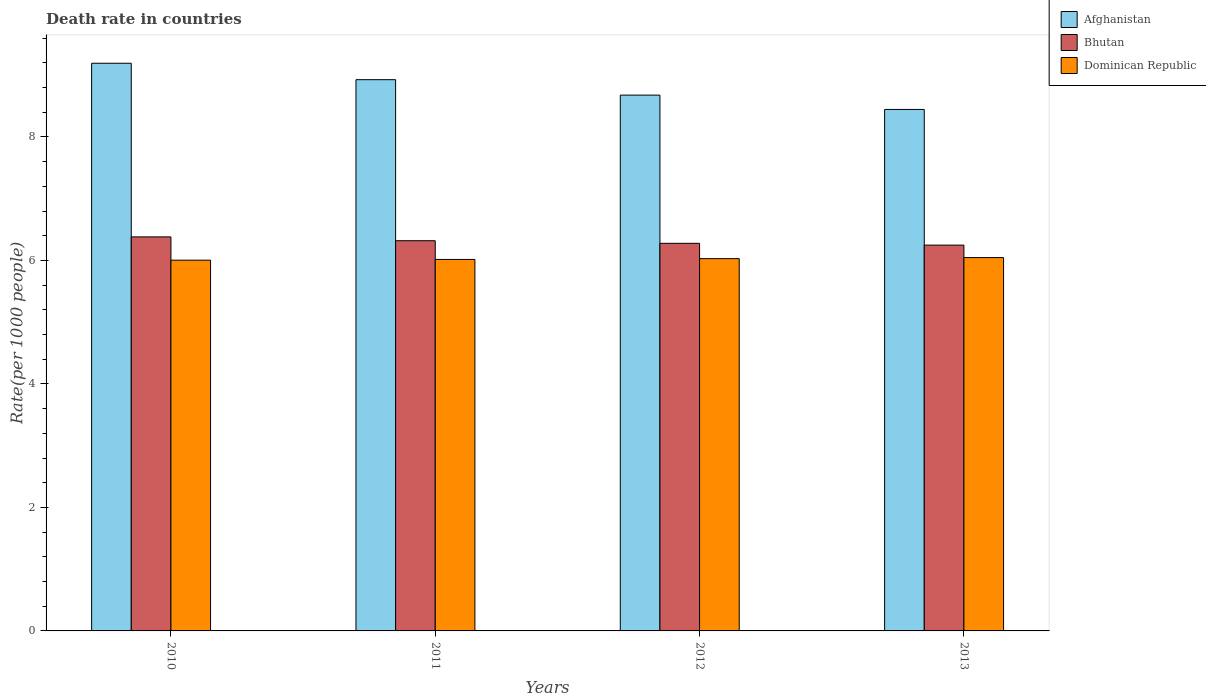What is the death rate in Dominican Republic in 2012?
Offer a very short reply. 6.03. Across all years, what is the maximum death rate in Afghanistan?
Keep it short and to the point. 9.19. Across all years, what is the minimum death rate in Afghanistan?
Ensure brevity in your answer.  8.45. In which year was the death rate in Bhutan maximum?
Your answer should be very brief. 2010. What is the total death rate in Afghanistan in the graph?
Offer a terse response. 35.24. What is the difference between the death rate in Afghanistan in 2011 and that in 2013?
Keep it short and to the point. 0.48. What is the difference between the death rate in Afghanistan in 2011 and the death rate in Dominican Republic in 2012?
Provide a short and direct response. 2.9. What is the average death rate in Dominican Republic per year?
Give a very brief answer. 6.02. In the year 2011, what is the difference between the death rate in Afghanistan and death rate in Dominican Republic?
Your answer should be very brief. 2.91. In how many years, is the death rate in Dominican Republic greater than 2.4?
Offer a terse response. 4. What is the ratio of the death rate in Afghanistan in 2012 to that in 2013?
Make the answer very short. 1.03. What is the difference between the highest and the second highest death rate in Dominican Republic?
Keep it short and to the point. 0.02. What is the difference between the highest and the lowest death rate in Afghanistan?
Make the answer very short. 0.75. In how many years, is the death rate in Afghanistan greater than the average death rate in Afghanistan taken over all years?
Give a very brief answer. 2. Is the sum of the death rate in Dominican Republic in 2012 and 2013 greater than the maximum death rate in Bhutan across all years?
Give a very brief answer. Yes. What does the 3rd bar from the left in 2012 represents?
Give a very brief answer. Dominican Republic. What does the 3rd bar from the right in 2010 represents?
Ensure brevity in your answer.  Afghanistan. Are all the bars in the graph horizontal?
Provide a short and direct response. No. How many years are there in the graph?
Provide a short and direct response. 4. What is the difference between two consecutive major ticks on the Y-axis?
Offer a very short reply. 2. Are the values on the major ticks of Y-axis written in scientific E-notation?
Offer a terse response. No. Does the graph contain grids?
Provide a succinct answer. No. Where does the legend appear in the graph?
Your answer should be very brief. Top right. How many legend labels are there?
Provide a short and direct response. 3. How are the legend labels stacked?
Offer a terse response. Vertical. What is the title of the graph?
Make the answer very short. Death rate in countries. What is the label or title of the Y-axis?
Provide a succinct answer. Rate(per 1000 people). What is the Rate(per 1000 people) of Afghanistan in 2010?
Your answer should be compact. 9.19. What is the Rate(per 1000 people) in Bhutan in 2010?
Offer a terse response. 6.38. What is the Rate(per 1000 people) of Dominican Republic in 2010?
Offer a terse response. 6. What is the Rate(per 1000 people) in Afghanistan in 2011?
Keep it short and to the point. 8.93. What is the Rate(per 1000 people) in Bhutan in 2011?
Provide a succinct answer. 6.32. What is the Rate(per 1000 people) of Dominican Republic in 2011?
Your response must be concise. 6.02. What is the Rate(per 1000 people) of Afghanistan in 2012?
Your answer should be compact. 8.68. What is the Rate(per 1000 people) in Bhutan in 2012?
Give a very brief answer. 6.28. What is the Rate(per 1000 people) in Dominican Republic in 2012?
Your answer should be very brief. 6.03. What is the Rate(per 1000 people) of Afghanistan in 2013?
Your answer should be very brief. 8.45. What is the Rate(per 1000 people) in Bhutan in 2013?
Give a very brief answer. 6.25. What is the Rate(per 1000 people) of Dominican Republic in 2013?
Give a very brief answer. 6.05. Across all years, what is the maximum Rate(per 1000 people) in Afghanistan?
Your answer should be compact. 9.19. Across all years, what is the maximum Rate(per 1000 people) in Bhutan?
Your response must be concise. 6.38. Across all years, what is the maximum Rate(per 1000 people) of Dominican Republic?
Provide a short and direct response. 6.05. Across all years, what is the minimum Rate(per 1000 people) in Afghanistan?
Keep it short and to the point. 8.45. Across all years, what is the minimum Rate(per 1000 people) of Bhutan?
Make the answer very short. 6.25. Across all years, what is the minimum Rate(per 1000 people) in Dominican Republic?
Give a very brief answer. 6. What is the total Rate(per 1000 people) of Afghanistan in the graph?
Keep it short and to the point. 35.24. What is the total Rate(per 1000 people) of Bhutan in the graph?
Give a very brief answer. 25.23. What is the total Rate(per 1000 people) of Dominican Republic in the graph?
Keep it short and to the point. 24.09. What is the difference between the Rate(per 1000 people) of Afghanistan in 2010 and that in 2011?
Your answer should be very brief. 0.27. What is the difference between the Rate(per 1000 people) in Bhutan in 2010 and that in 2011?
Provide a succinct answer. 0.06. What is the difference between the Rate(per 1000 people) of Dominican Republic in 2010 and that in 2011?
Make the answer very short. -0.01. What is the difference between the Rate(per 1000 people) in Afghanistan in 2010 and that in 2012?
Offer a terse response. 0.52. What is the difference between the Rate(per 1000 people) of Bhutan in 2010 and that in 2012?
Your answer should be very brief. 0.1. What is the difference between the Rate(per 1000 people) of Dominican Republic in 2010 and that in 2012?
Your response must be concise. -0.03. What is the difference between the Rate(per 1000 people) of Afghanistan in 2010 and that in 2013?
Your response must be concise. 0.75. What is the difference between the Rate(per 1000 people) in Bhutan in 2010 and that in 2013?
Give a very brief answer. 0.13. What is the difference between the Rate(per 1000 people) of Dominican Republic in 2010 and that in 2013?
Provide a succinct answer. -0.04. What is the difference between the Rate(per 1000 people) in Bhutan in 2011 and that in 2012?
Offer a terse response. 0.04. What is the difference between the Rate(per 1000 people) of Dominican Republic in 2011 and that in 2012?
Make the answer very short. -0.01. What is the difference between the Rate(per 1000 people) in Afghanistan in 2011 and that in 2013?
Give a very brief answer. 0.48. What is the difference between the Rate(per 1000 people) in Bhutan in 2011 and that in 2013?
Give a very brief answer. 0.07. What is the difference between the Rate(per 1000 people) of Dominican Republic in 2011 and that in 2013?
Your response must be concise. -0.03. What is the difference between the Rate(per 1000 people) in Afghanistan in 2012 and that in 2013?
Ensure brevity in your answer.  0.23. What is the difference between the Rate(per 1000 people) of Bhutan in 2012 and that in 2013?
Make the answer very short. 0.03. What is the difference between the Rate(per 1000 people) in Dominican Republic in 2012 and that in 2013?
Give a very brief answer. -0.02. What is the difference between the Rate(per 1000 people) of Afghanistan in 2010 and the Rate(per 1000 people) of Bhutan in 2011?
Your answer should be compact. 2.87. What is the difference between the Rate(per 1000 people) of Afghanistan in 2010 and the Rate(per 1000 people) of Dominican Republic in 2011?
Make the answer very short. 3.18. What is the difference between the Rate(per 1000 people) in Bhutan in 2010 and the Rate(per 1000 people) in Dominican Republic in 2011?
Offer a very short reply. 0.36. What is the difference between the Rate(per 1000 people) of Afghanistan in 2010 and the Rate(per 1000 people) of Bhutan in 2012?
Offer a terse response. 2.92. What is the difference between the Rate(per 1000 people) in Afghanistan in 2010 and the Rate(per 1000 people) in Dominican Republic in 2012?
Offer a very short reply. 3.16. What is the difference between the Rate(per 1000 people) in Bhutan in 2010 and the Rate(per 1000 people) in Dominican Republic in 2012?
Give a very brief answer. 0.35. What is the difference between the Rate(per 1000 people) of Afghanistan in 2010 and the Rate(per 1000 people) of Bhutan in 2013?
Give a very brief answer. 2.94. What is the difference between the Rate(per 1000 people) of Afghanistan in 2010 and the Rate(per 1000 people) of Dominican Republic in 2013?
Offer a very short reply. 3.15. What is the difference between the Rate(per 1000 people) of Bhutan in 2010 and the Rate(per 1000 people) of Dominican Republic in 2013?
Your response must be concise. 0.34. What is the difference between the Rate(per 1000 people) of Afghanistan in 2011 and the Rate(per 1000 people) of Bhutan in 2012?
Your response must be concise. 2.65. What is the difference between the Rate(per 1000 people) of Afghanistan in 2011 and the Rate(per 1000 people) of Dominican Republic in 2012?
Make the answer very short. 2.9. What is the difference between the Rate(per 1000 people) in Bhutan in 2011 and the Rate(per 1000 people) in Dominican Republic in 2012?
Your answer should be compact. 0.29. What is the difference between the Rate(per 1000 people) in Afghanistan in 2011 and the Rate(per 1000 people) in Bhutan in 2013?
Give a very brief answer. 2.68. What is the difference between the Rate(per 1000 people) of Afghanistan in 2011 and the Rate(per 1000 people) of Dominican Republic in 2013?
Give a very brief answer. 2.88. What is the difference between the Rate(per 1000 people) in Bhutan in 2011 and the Rate(per 1000 people) in Dominican Republic in 2013?
Your response must be concise. 0.27. What is the difference between the Rate(per 1000 people) of Afghanistan in 2012 and the Rate(per 1000 people) of Bhutan in 2013?
Offer a terse response. 2.43. What is the difference between the Rate(per 1000 people) in Afghanistan in 2012 and the Rate(per 1000 people) in Dominican Republic in 2013?
Ensure brevity in your answer.  2.63. What is the difference between the Rate(per 1000 people) of Bhutan in 2012 and the Rate(per 1000 people) of Dominican Republic in 2013?
Give a very brief answer. 0.23. What is the average Rate(per 1000 people) of Afghanistan per year?
Provide a succinct answer. 8.81. What is the average Rate(per 1000 people) of Bhutan per year?
Ensure brevity in your answer.  6.31. What is the average Rate(per 1000 people) of Dominican Republic per year?
Give a very brief answer. 6.02. In the year 2010, what is the difference between the Rate(per 1000 people) in Afghanistan and Rate(per 1000 people) in Bhutan?
Provide a short and direct response. 2.81. In the year 2010, what is the difference between the Rate(per 1000 people) of Afghanistan and Rate(per 1000 people) of Dominican Republic?
Your response must be concise. 3.19. In the year 2010, what is the difference between the Rate(per 1000 people) in Bhutan and Rate(per 1000 people) in Dominican Republic?
Provide a succinct answer. 0.38. In the year 2011, what is the difference between the Rate(per 1000 people) in Afghanistan and Rate(per 1000 people) in Bhutan?
Ensure brevity in your answer.  2.61. In the year 2011, what is the difference between the Rate(per 1000 people) in Afghanistan and Rate(per 1000 people) in Dominican Republic?
Offer a terse response. 2.91. In the year 2011, what is the difference between the Rate(per 1000 people) in Bhutan and Rate(per 1000 people) in Dominican Republic?
Ensure brevity in your answer.  0.3. In the year 2012, what is the difference between the Rate(per 1000 people) of Afghanistan and Rate(per 1000 people) of Bhutan?
Offer a terse response. 2.4. In the year 2012, what is the difference between the Rate(per 1000 people) of Afghanistan and Rate(per 1000 people) of Dominican Republic?
Offer a terse response. 2.65. In the year 2012, what is the difference between the Rate(per 1000 people) of Bhutan and Rate(per 1000 people) of Dominican Republic?
Your answer should be compact. 0.25. In the year 2013, what is the difference between the Rate(per 1000 people) in Afghanistan and Rate(per 1000 people) in Bhutan?
Make the answer very short. 2.2. In the year 2013, what is the difference between the Rate(per 1000 people) in Afghanistan and Rate(per 1000 people) in Dominican Republic?
Give a very brief answer. 2.4. In the year 2013, what is the difference between the Rate(per 1000 people) of Bhutan and Rate(per 1000 people) of Dominican Republic?
Your answer should be very brief. 0.2. What is the ratio of the Rate(per 1000 people) of Afghanistan in 2010 to that in 2011?
Make the answer very short. 1.03. What is the ratio of the Rate(per 1000 people) in Bhutan in 2010 to that in 2011?
Your answer should be compact. 1.01. What is the ratio of the Rate(per 1000 people) in Dominican Republic in 2010 to that in 2011?
Give a very brief answer. 1. What is the ratio of the Rate(per 1000 people) of Afghanistan in 2010 to that in 2012?
Keep it short and to the point. 1.06. What is the ratio of the Rate(per 1000 people) in Bhutan in 2010 to that in 2012?
Provide a succinct answer. 1.02. What is the ratio of the Rate(per 1000 people) in Afghanistan in 2010 to that in 2013?
Your answer should be compact. 1.09. What is the ratio of the Rate(per 1000 people) of Bhutan in 2010 to that in 2013?
Provide a succinct answer. 1.02. What is the ratio of the Rate(per 1000 people) of Afghanistan in 2011 to that in 2012?
Keep it short and to the point. 1.03. What is the ratio of the Rate(per 1000 people) in Bhutan in 2011 to that in 2012?
Offer a very short reply. 1.01. What is the ratio of the Rate(per 1000 people) in Afghanistan in 2011 to that in 2013?
Provide a succinct answer. 1.06. What is the ratio of the Rate(per 1000 people) in Bhutan in 2011 to that in 2013?
Provide a short and direct response. 1.01. What is the ratio of the Rate(per 1000 people) of Dominican Republic in 2011 to that in 2013?
Offer a terse response. 0.99. What is the ratio of the Rate(per 1000 people) in Afghanistan in 2012 to that in 2013?
Your response must be concise. 1.03. What is the ratio of the Rate(per 1000 people) in Bhutan in 2012 to that in 2013?
Give a very brief answer. 1. What is the ratio of the Rate(per 1000 people) of Dominican Republic in 2012 to that in 2013?
Keep it short and to the point. 1. What is the difference between the highest and the second highest Rate(per 1000 people) of Afghanistan?
Make the answer very short. 0.27. What is the difference between the highest and the second highest Rate(per 1000 people) of Bhutan?
Make the answer very short. 0.06. What is the difference between the highest and the second highest Rate(per 1000 people) of Dominican Republic?
Offer a terse response. 0.02. What is the difference between the highest and the lowest Rate(per 1000 people) in Afghanistan?
Provide a short and direct response. 0.75. What is the difference between the highest and the lowest Rate(per 1000 people) of Bhutan?
Your answer should be very brief. 0.13. What is the difference between the highest and the lowest Rate(per 1000 people) of Dominican Republic?
Give a very brief answer. 0.04. 